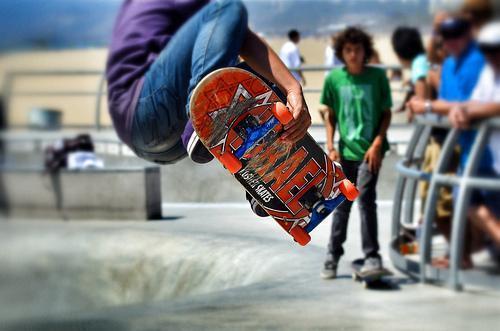How many skaters?
Give a very brief answer. 3. 